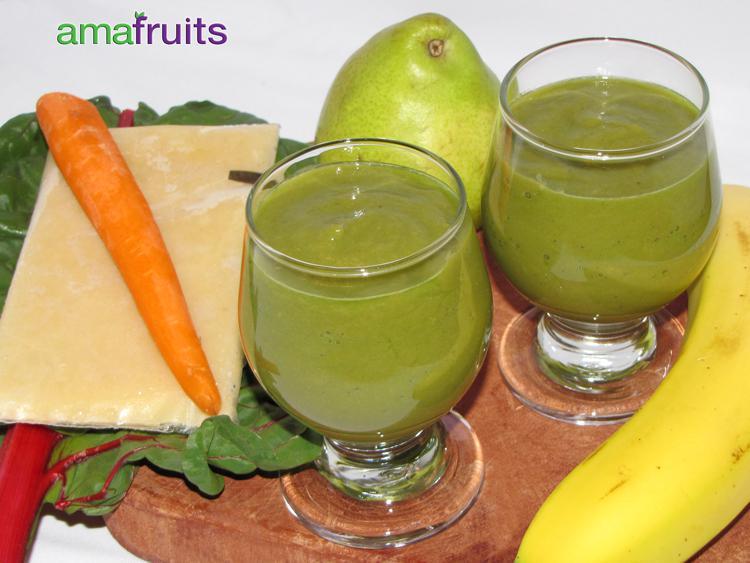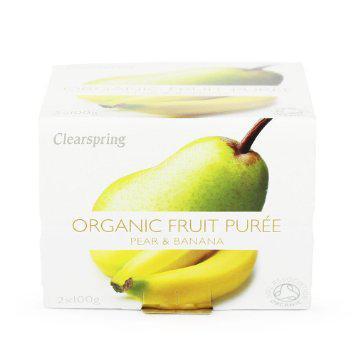The first image is the image on the left, the second image is the image on the right. Analyze the images presented: Is the assertion "The image on the left has at least one striped straw." valid? Answer yes or no. No. The first image is the image on the left, the second image is the image on the right. Given the left and right images, does the statement "An image shows exactly one creamy green drink served in a footed glass." hold true? Answer yes or no. No. 